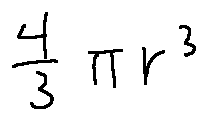Convert formula to latex. <formula><loc_0><loc_0><loc_500><loc_500>\frac { 4 } { 3 } \pi r ^ { 3 }</formula> 